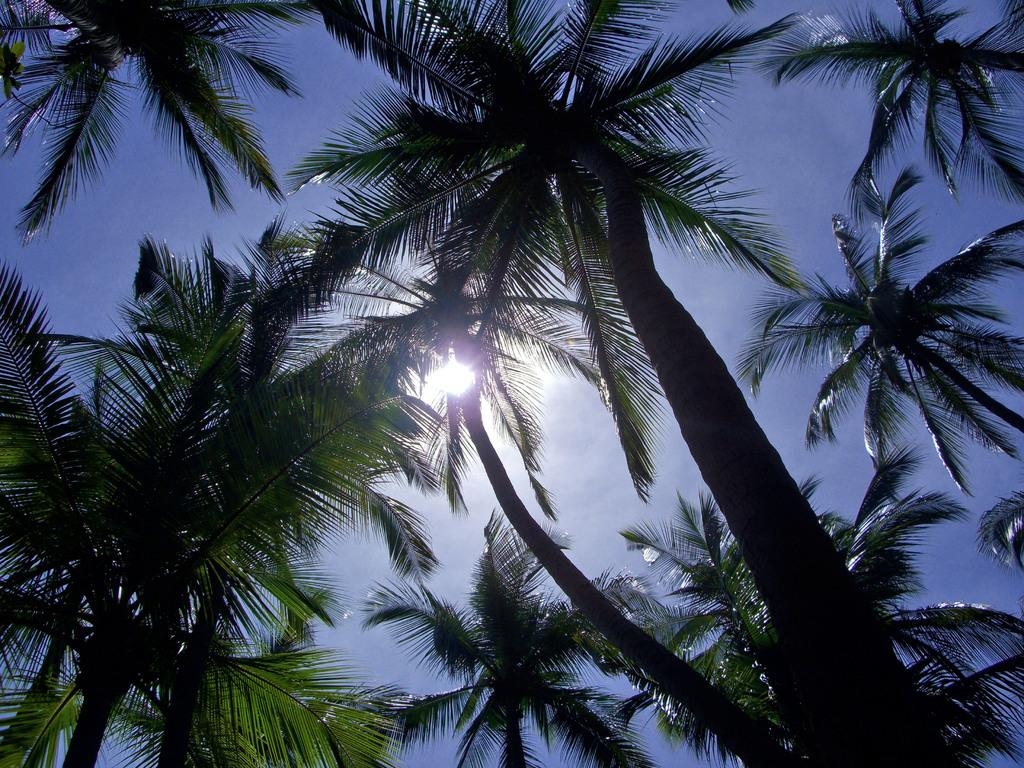What type of vegetation is present in the image? There are trees with green leaves in the image. What color is the sky in the background? The sky is blue in the background. What can be seen in the sky besides the blue color? There are clouds visible in the sky. What celestial body is present in the sky? The sun is present in the sky. What type of brush is being used to paint the clouds in the image? There is no brush or painting activity present in the image; it is a photograph of a natural scene. 